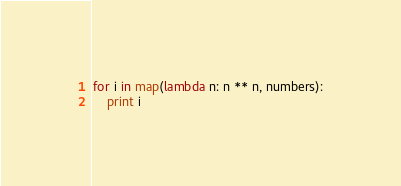<code> <loc_0><loc_0><loc_500><loc_500><_Python_>for i in map(lambda n: n ** n, numbers):
	print i
</code> 